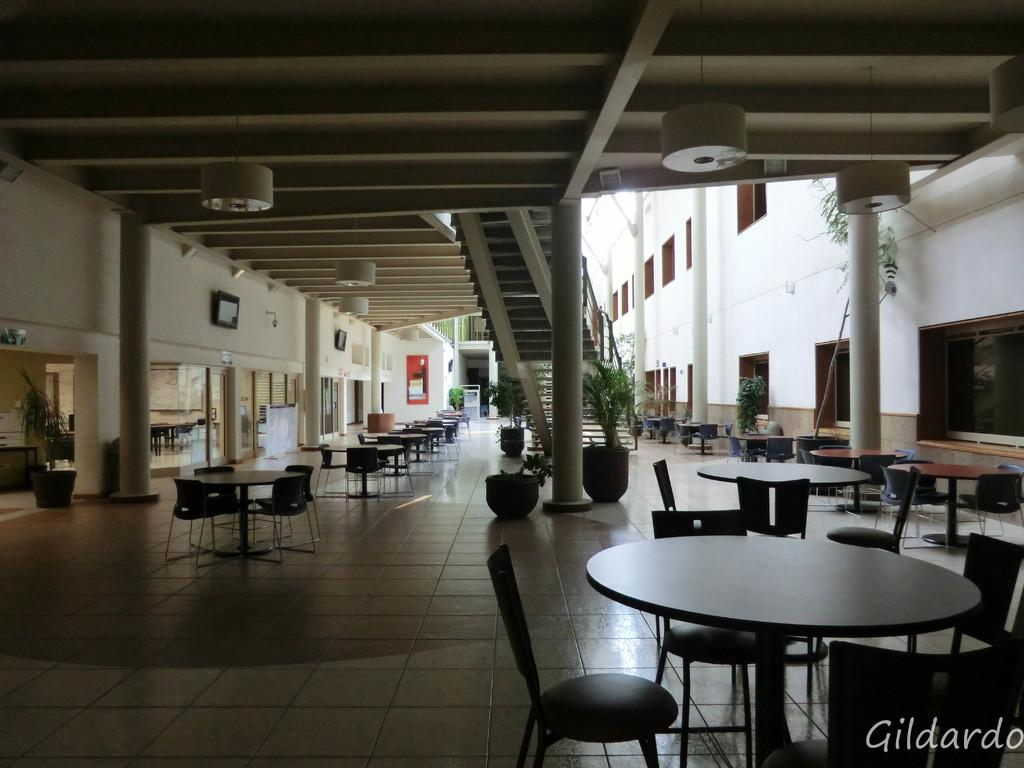What type of furniture is present in the image? There are tables and chairs in the image. What architectural feature can be seen in the image? There is a staircase in the image. What can be seen through the windows in the image? The presence of windows suggests that there is a view outside, but the specific view cannot be determined from the facts provided. What type of decorative items are present in the image? There are house plants, a poster, and photo frames on the wall in the image. How does the poster control the history of the house in the image? The poster does not control the history of the house in the image; it is simply a decorative item. Can you fold the staircase in the image? The staircase is a fixed architectural feature and cannot be folded. 